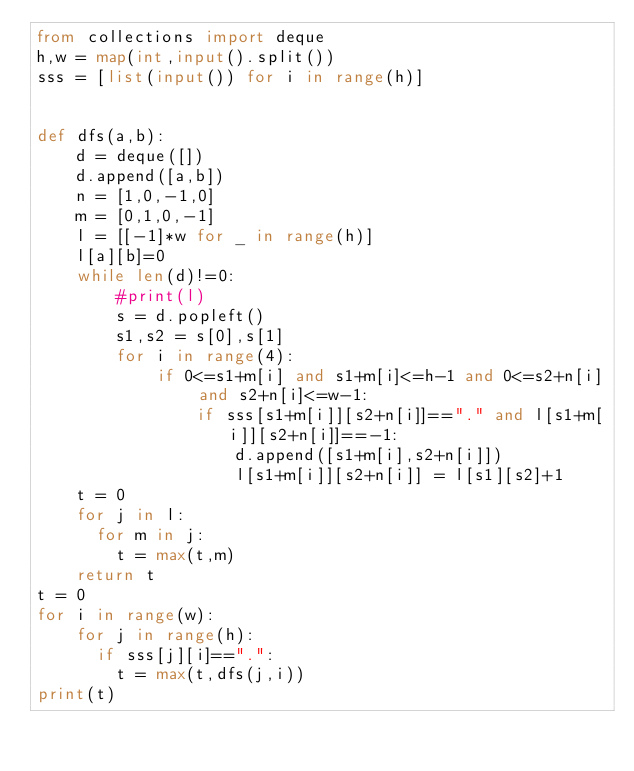Convert code to text. <code><loc_0><loc_0><loc_500><loc_500><_Python_>from collections import deque
h,w = map(int,input().split())
sss = [list(input()) for i in range(h)]


def dfs(a,b):
    d = deque([])
    d.append([a,b])
    n = [1,0,-1,0]
    m = [0,1,0,-1]
    l = [[-1]*w for _ in range(h)]
    l[a][b]=0
    while len(d)!=0:
        #print(l)
        s = d.popleft()
        s1,s2 = s[0],s[1]
        for i in range(4):
            if 0<=s1+m[i] and s1+m[i]<=h-1 and 0<=s2+n[i] and s2+n[i]<=w-1:
                if sss[s1+m[i]][s2+n[i]]=="." and l[s1+m[i]][s2+n[i]]==-1:
                    d.append([s1+m[i],s2+n[i]])
                    l[s1+m[i]][s2+n[i]] = l[s1][s2]+1
    t = 0
    for j in l:
      for m in j:
        t = max(t,m)
    return t
t = 0
for i in range(w):
    for j in range(h):
      if sss[j][i]==".":
        t = max(t,dfs(j,i))
print(t)
</code> 